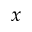Convert formula to latex. <formula><loc_0><loc_0><loc_500><loc_500>x</formula> 